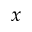Convert formula to latex. <formula><loc_0><loc_0><loc_500><loc_500>x</formula> 